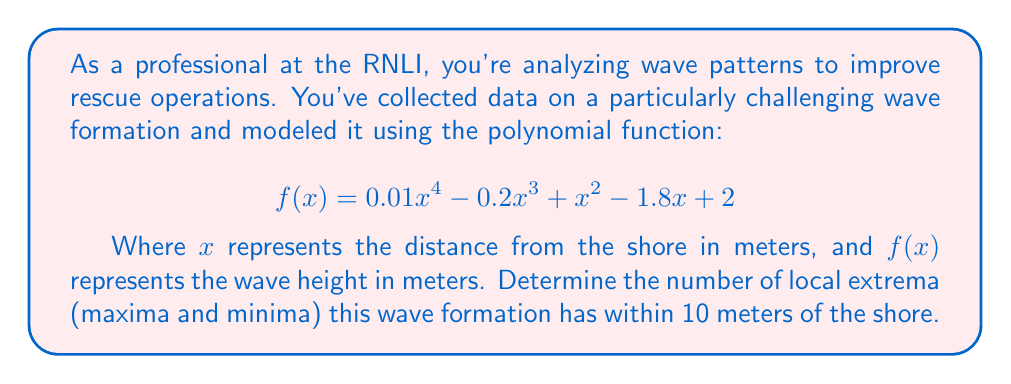Can you solve this math problem? To find the number of local extrema, we need to analyze the derivative of the function:

1) First, find the derivative $f'(x)$:
   $$f'(x) = 0.04x^3 - 0.6x^2 + 2x - 1.8$$

2) To find local extrema, set $f'(x) = 0$:
   $$0.04x^3 - 0.6x^2 + 2x - 1.8 = 0$$

3) This is a cubic equation. It can have at most 3 real roots.

4) To solve this, we can use a graphing calculator or computer algebra system. The roots are approximately:
   $x \approx 0.61$, $x \approx 3.89$, and $x \approx 10.50$

5) Since we're only considering the region within 10 meters of the shore, we only consider the first two roots.

6) Each of these roots represents a local extremum (either a maximum or minimum).

7) Therefore, within 10 meters of the shore, there are 2 local extrema.

To confirm these are indeed extrema and not inflection points, we could check the second derivative at these points, but it's not necessary for counting the number of extrema in this case.
Answer: 2 local extrema 